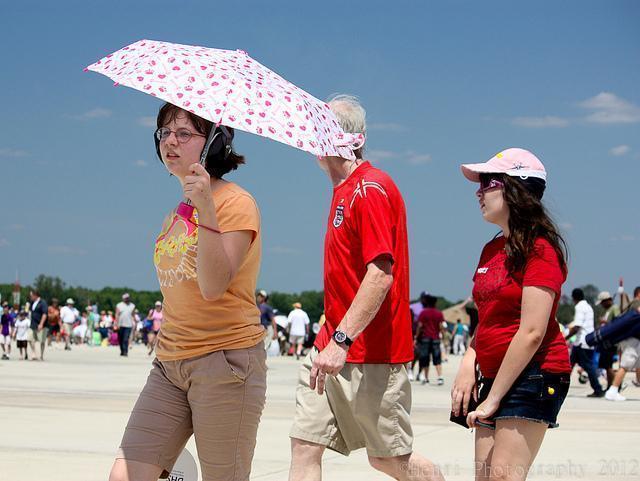The person holding the umbrella looks most like who?
Indicate the correct response by choosing from the four available options to answer the question.
Options: Lily frazer, albert finney, amber tamblyn, adewale akinnuoyeagbaje. Amber tamblyn. 